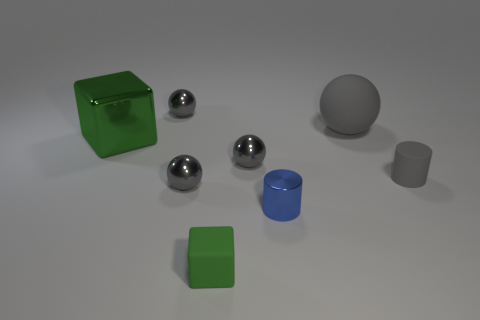There is a small gray thing in front of the tiny gray cylinder; what shape is it?
Provide a succinct answer. Sphere. What number of other things are the same size as the metallic block?
Keep it short and to the point. 1. There is a gray rubber object that is behind the green shiny object; is its shape the same as the tiny gray thing behind the large block?
Keep it short and to the point. Yes. There is a large sphere; how many gray spheres are right of it?
Make the answer very short. 0. There is a big thing that is to the left of the large gray ball; what color is it?
Provide a short and direct response. Green. What is the color of the other object that is the same shape as the small green matte thing?
Keep it short and to the point. Green. Are there any other things that are the same color as the large ball?
Ensure brevity in your answer.  Yes. Is the number of small brown rubber things greater than the number of tiny green rubber blocks?
Your answer should be compact. No. Is the material of the large gray thing the same as the small block?
Your answer should be very brief. Yes. How many tiny gray balls have the same material as the blue object?
Make the answer very short. 3. 